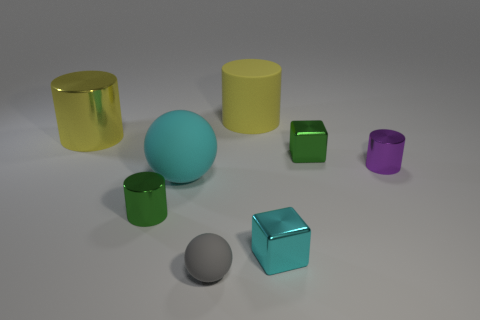What materials are the objects made of in the image, and how can you tell? The objects appear to be digital renderings made to simulate various materials. The reflective surfaces on some cylinders suggest a metallic or glossy finish, while others, like the gray object, have a dull or matte finish implying a more plastic-like material. 